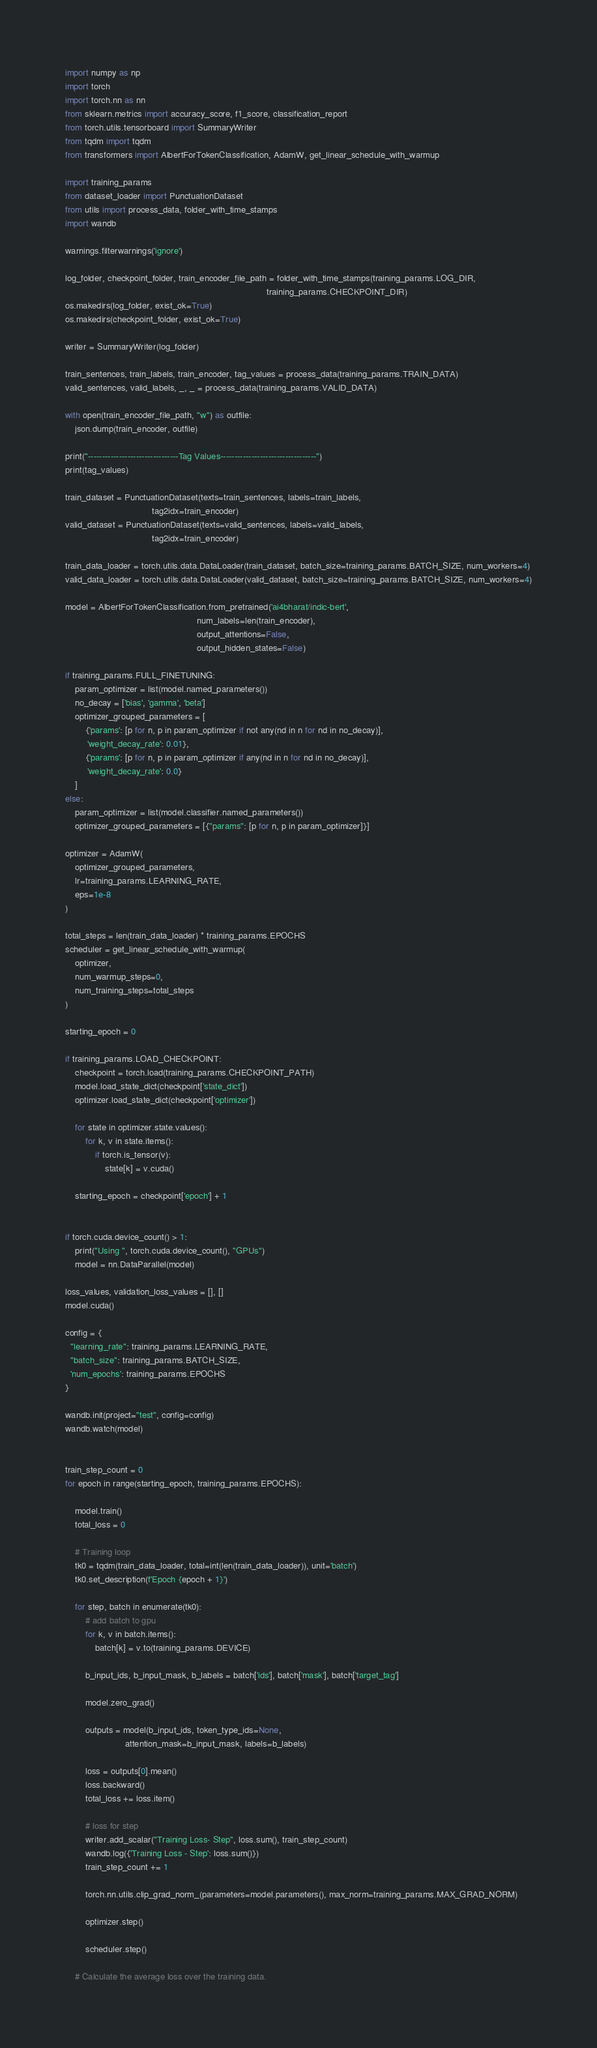Convert code to text. <code><loc_0><loc_0><loc_500><loc_500><_Python_>import numpy as np
import torch
import torch.nn as nn
from sklearn.metrics import accuracy_score, f1_score, classification_report
from torch.utils.tensorboard import SummaryWriter
from tqdm import tqdm
from transformers import AlbertForTokenClassification, AdamW, get_linear_schedule_with_warmup

import training_params
from dataset_loader import PunctuationDataset
from utils import process_data, folder_with_time_stamps
import wandb

warnings.filterwarnings('ignore')

log_folder, checkpoint_folder, train_encoder_file_path = folder_with_time_stamps(training_params.LOG_DIR,
                                                                                 training_params.CHECKPOINT_DIR)
os.makedirs(log_folder, exist_ok=True)
os.makedirs(checkpoint_folder, exist_ok=True)

writer = SummaryWriter(log_folder)

train_sentences, train_labels, train_encoder, tag_values = process_data(training_params.TRAIN_DATA)
valid_sentences, valid_labels, _, _ = process_data(training_params.VALID_DATA)

with open(train_encoder_file_path, "w") as outfile:
    json.dump(train_encoder, outfile)

print("--------------------------------Tag Values----------------------------------")
print(tag_values)

train_dataset = PunctuationDataset(texts=train_sentences, labels=train_labels,
                                   tag2idx=train_encoder)
valid_dataset = PunctuationDataset(texts=valid_sentences, labels=valid_labels,
                                   tag2idx=train_encoder)

train_data_loader = torch.utils.data.DataLoader(train_dataset, batch_size=training_params.BATCH_SIZE, num_workers=4)
valid_data_loader = torch.utils.data.DataLoader(valid_dataset, batch_size=training_params.BATCH_SIZE, num_workers=4)

model = AlbertForTokenClassification.from_pretrained('ai4bharat/indic-bert',
                                                     num_labels=len(train_encoder),
                                                     output_attentions=False,
                                                     output_hidden_states=False)

if training_params.FULL_FINETUNING:
    param_optimizer = list(model.named_parameters())
    no_decay = ['bias', 'gamma', 'beta']
    optimizer_grouped_parameters = [
        {'params': [p for n, p in param_optimizer if not any(nd in n for nd in no_decay)],
         'weight_decay_rate': 0.01},
        {'params': [p for n, p in param_optimizer if any(nd in n for nd in no_decay)],
         'weight_decay_rate': 0.0}
    ]
else:
    param_optimizer = list(model.classifier.named_parameters())
    optimizer_grouped_parameters = [{"params": [p for n, p in param_optimizer]}]

optimizer = AdamW(
    optimizer_grouped_parameters,
    lr=training_params.LEARNING_RATE,
    eps=1e-8
)

total_steps = len(train_data_loader) * training_params.EPOCHS
scheduler = get_linear_schedule_with_warmup(
    optimizer,
    num_warmup_steps=0,
    num_training_steps=total_steps
)

starting_epoch = 0

if training_params.LOAD_CHECKPOINT:
    checkpoint = torch.load(training_params.CHECKPOINT_PATH)
    model.load_state_dict(checkpoint['state_dict'])
    optimizer.load_state_dict(checkpoint['optimizer'])

    for state in optimizer.state.values():
        for k, v in state.items():
            if torch.is_tensor(v):
                state[k] = v.cuda()

    starting_epoch = checkpoint['epoch'] + 1


if torch.cuda.device_count() > 1:
    print("Using ", torch.cuda.device_count(), "GPUs")
    model = nn.DataParallel(model)

loss_values, validation_loss_values = [], []
model.cuda()

config = {
  "learning_rate": training_params.LEARNING_RATE,
  "batch_size": training_params.BATCH_SIZE,
  'num_epochs': training_params.EPOCHS
}

wandb.init(project="test", config=config)
wandb.watch(model)


train_step_count = 0
for epoch in range(starting_epoch, training_params.EPOCHS):

    model.train()
    total_loss = 0

    # Training loop
    tk0 = tqdm(train_data_loader, total=int(len(train_data_loader)), unit='batch')
    tk0.set_description(f'Epoch {epoch + 1}')

    for step, batch in enumerate(tk0):
        # add batch to gpu
        for k, v in batch.items():
            batch[k] = v.to(training_params.DEVICE)

        b_input_ids, b_input_mask, b_labels = batch['ids'], batch['mask'], batch['target_tag']

        model.zero_grad()

        outputs = model(b_input_ids, token_type_ids=None,
                        attention_mask=b_input_mask, labels=b_labels)

        loss = outputs[0].mean()
        loss.backward()
        total_loss += loss.item()

        # loss for step
        writer.add_scalar("Training Loss- Step", loss.sum(), train_step_count)
        wandb.log({'Training Loss - Step': loss.sum()})  
        train_step_count += 1

        torch.nn.utils.clip_grad_norm_(parameters=model.parameters(), max_norm=training_params.MAX_GRAD_NORM)

        optimizer.step()

        scheduler.step()

    # Calculate the average loss over the training data.</code> 